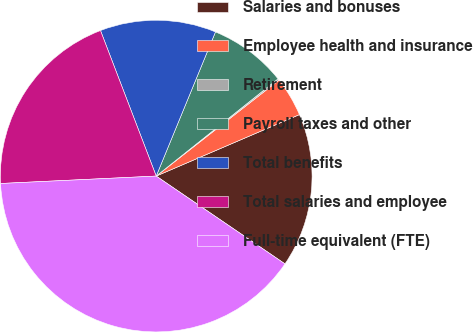Convert chart. <chart><loc_0><loc_0><loc_500><loc_500><pie_chart><fcel>Salaries and bonuses<fcel>Employee health and insurance<fcel>Retirement<fcel>Payroll taxes and other<fcel>Total benefits<fcel>Total salaries and employee<fcel>Full-time equivalent (FTE)<nl><fcel>15.98%<fcel>4.11%<fcel>0.16%<fcel>8.07%<fcel>12.03%<fcel>19.94%<fcel>39.72%<nl></chart> 